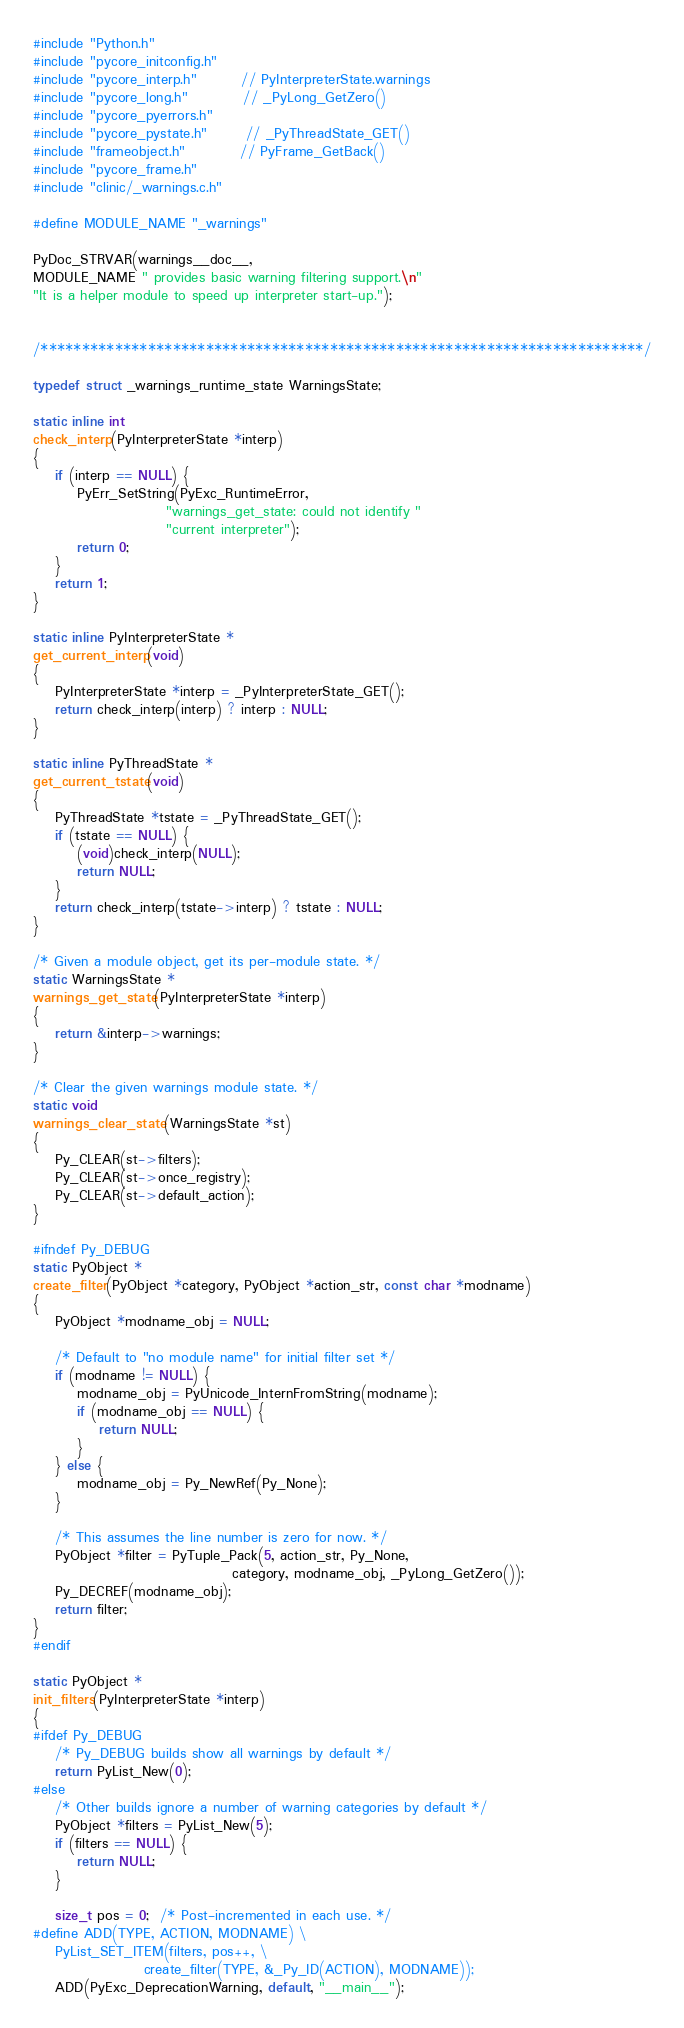Convert code to text. <code><loc_0><loc_0><loc_500><loc_500><_C_>#include "Python.h"
#include "pycore_initconfig.h"
#include "pycore_interp.h"        // PyInterpreterState.warnings
#include "pycore_long.h"          // _PyLong_GetZero()
#include "pycore_pyerrors.h"
#include "pycore_pystate.h"       // _PyThreadState_GET()
#include "frameobject.h"          // PyFrame_GetBack()
#include "pycore_frame.h"
#include "clinic/_warnings.c.h"

#define MODULE_NAME "_warnings"

PyDoc_STRVAR(warnings__doc__,
MODULE_NAME " provides basic warning filtering support.\n"
"It is a helper module to speed up interpreter start-up.");


/*************************************************************************/

typedef struct _warnings_runtime_state WarningsState;

static inline int
check_interp(PyInterpreterState *interp)
{
    if (interp == NULL) {
        PyErr_SetString(PyExc_RuntimeError,
                        "warnings_get_state: could not identify "
                        "current interpreter");
        return 0;
    }
    return 1;
}

static inline PyInterpreterState *
get_current_interp(void)
{
    PyInterpreterState *interp = _PyInterpreterState_GET();
    return check_interp(interp) ? interp : NULL;
}

static inline PyThreadState *
get_current_tstate(void)
{
    PyThreadState *tstate = _PyThreadState_GET();
    if (tstate == NULL) {
        (void)check_interp(NULL);
        return NULL;
    }
    return check_interp(tstate->interp) ? tstate : NULL;
}

/* Given a module object, get its per-module state. */
static WarningsState *
warnings_get_state(PyInterpreterState *interp)
{
    return &interp->warnings;
}

/* Clear the given warnings module state. */
static void
warnings_clear_state(WarningsState *st)
{
    Py_CLEAR(st->filters);
    Py_CLEAR(st->once_registry);
    Py_CLEAR(st->default_action);
}

#ifndef Py_DEBUG
static PyObject *
create_filter(PyObject *category, PyObject *action_str, const char *modname)
{
    PyObject *modname_obj = NULL;

    /* Default to "no module name" for initial filter set */
    if (modname != NULL) {
        modname_obj = PyUnicode_InternFromString(modname);
        if (modname_obj == NULL) {
            return NULL;
        }
    } else {
        modname_obj = Py_NewRef(Py_None);
    }

    /* This assumes the line number is zero for now. */
    PyObject *filter = PyTuple_Pack(5, action_str, Py_None,
                                    category, modname_obj, _PyLong_GetZero());
    Py_DECREF(modname_obj);
    return filter;
}
#endif

static PyObject *
init_filters(PyInterpreterState *interp)
{
#ifdef Py_DEBUG
    /* Py_DEBUG builds show all warnings by default */
    return PyList_New(0);
#else
    /* Other builds ignore a number of warning categories by default */
    PyObject *filters = PyList_New(5);
    if (filters == NULL) {
        return NULL;
    }

    size_t pos = 0;  /* Post-incremented in each use. */
#define ADD(TYPE, ACTION, MODNAME) \
    PyList_SET_ITEM(filters, pos++, \
                    create_filter(TYPE, &_Py_ID(ACTION), MODNAME));
    ADD(PyExc_DeprecationWarning, default, "__main__");</code> 